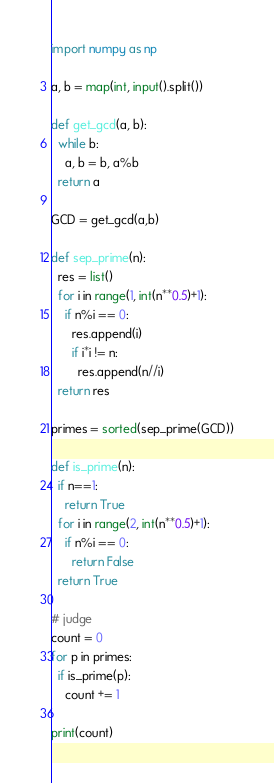Convert code to text. <code><loc_0><loc_0><loc_500><loc_500><_Python_>import numpy as np

a, b = map(int, input().split())

def get_gcd(a, b):
  while b:
    a, b = b, a%b
  return a

GCD = get_gcd(a,b)

def sep_prime(n):
  res = list()
  for i in range(1, int(n**0.5)+1):
    if n%i == 0:
      res.append(i)
      if i*i != n:
        res.append(n//i)
  return res

primes = sorted(sep_prime(GCD))

def is_prime(n):
  if n==1:
    return True
  for i in range(2, int(n**0.5)+1):
    if n%i == 0:
      return False
  return True

# judge
count = 0
for p in primes:
  if is_prime(p):
    count += 1

print(count)
</code> 